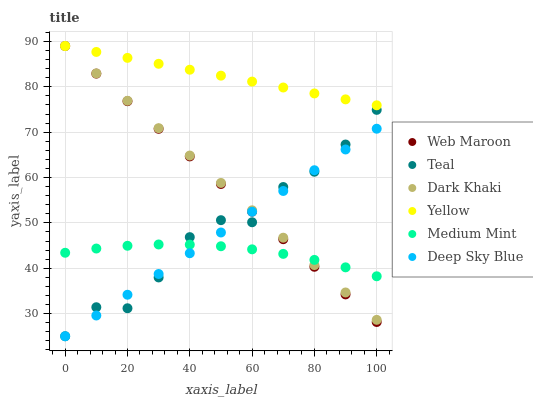Does Medium Mint have the minimum area under the curve?
Answer yes or no. Yes. Does Yellow have the maximum area under the curve?
Answer yes or no. Yes. Does Deep Sky Blue have the minimum area under the curve?
Answer yes or no. No. Does Deep Sky Blue have the maximum area under the curve?
Answer yes or no. No. Is Dark Khaki the smoothest?
Answer yes or no. Yes. Is Teal the roughest?
Answer yes or no. Yes. Is Deep Sky Blue the smoothest?
Answer yes or no. No. Is Deep Sky Blue the roughest?
Answer yes or no. No. Does Deep Sky Blue have the lowest value?
Answer yes or no. Yes. Does Web Maroon have the lowest value?
Answer yes or no. No. Does Dark Khaki have the highest value?
Answer yes or no. Yes. Does Deep Sky Blue have the highest value?
Answer yes or no. No. Is Deep Sky Blue less than Yellow?
Answer yes or no. Yes. Is Yellow greater than Deep Sky Blue?
Answer yes or no. Yes. Does Web Maroon intersect Medium Mint?
Answer yes or no. Yes. Is Web Maroon less than Medium Mint?
Answer yes or no. No. Is Web Maroon greater than Medium Mint?
Answer yes or no. No. Does Deep Sky Blue intersect Yellow?
Answer yes or no. No. 